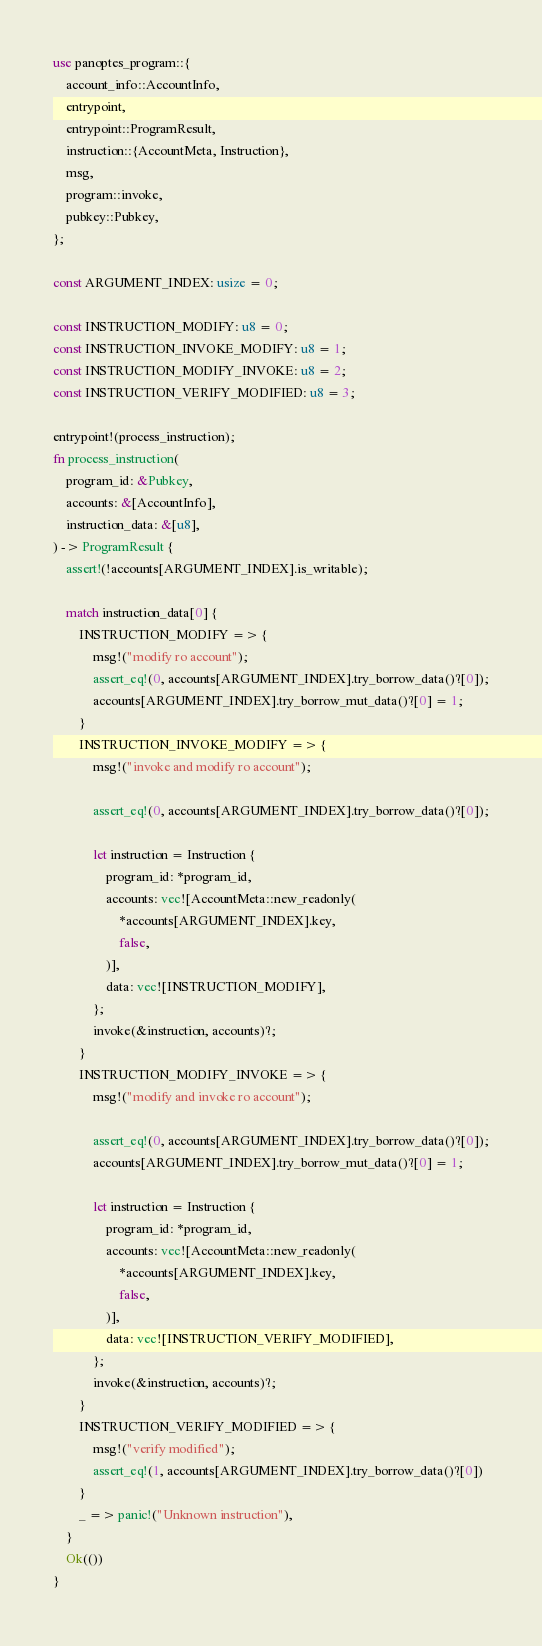Convert code to text. <code><loc_0><loc_0><loc_500><loc_500><_Rust_>use panoptes_program::{
    account_info::AccountInfo,
    entrypoint,
    entrypoint::ProgramResult,
    instruction::{AccountMeta, Instruction},
    msg,
    program::invoke,
    pubkey::Pubkey,
};

const ARGUMENT_INDEX: usize = 0;

const INSTRUCTION_MODIFY: u8 = 0;
const INSTRUCTION_INVOKE_MODIFY: u8 = 1;
const INSTRUCTION_MODIFY_INVOKE: u8 = 2;
const INSTRUCTION_VERIFY_MODIFIED: u8 = 3;

entrypoint!(process_instruction);
fn process_instruction(
    program_id: &Pubkey,
    accounts: &[AccountInfo],
    instruction_data: &[u8],
) -> ProgramResult {
    assert!(!accounts[ARGUMENT_INDEX].is_writable);

    match instruction_data[0] {
        INSTRUCTION_MODIFY => {
            msg!("modify ro account");
            assert_eq!(0, accounts[ARGUMENT_INDEX].try_borrow_data()?[0]);
            accounts[ARGUMENT_INDEX].try_borrow_mut_data()?[0] = 1;
        }
        INSTRUCTION_INVOKE_MODIFY => {
            msg!("invoke and modify ro account");

            assert_eq!(0, accounts[ARGUMENT_INDEX].try_borrow_data()?[0]);

            let instruction = Instruction {
                program_id: *program_id,
                accounts: vec![AccountMeta::new_readonly(
                    *accounts[ARGUMENT_INDEX].key,
                    false,
                )],
                data: vec![INSTRUCTION_MODIFY],
            };
            invoke(&instruction, accounts)?;
        }
        INSTRUCTION_MODIFY_INVOKE => {
            msg!("modify and invoke ro account");

            assert_eq!(0, accounts[ARGUMENT_INDEX].try_borrow_data()?[0]);
            accounts[ARGUMENT_INDEX].try_borrow_mut_data()?[0] = 1;

            let instruction = Instruction {
                program_id: *program_id,
                accounts: vec![AccountMeta::new_readonly(
                    *accounts[ARGUMENT_INDEX].key,
                    false,
                )],
                data: vec![INSTRUCTION_VERIFY_MODIFIED],
            };
            invoke(&instruction, accounts)?;
        }
        INSTRUCTION_VERIFY_MODIFIED => {
            msg!("verify modified");
            assert_eq!(1, accounts[ARGUMENT_INDEX].try_borrow_data()?[0])
        }
        _ => panic!("Unknown instruction"),
    }
    Ok(())
}
</code> 